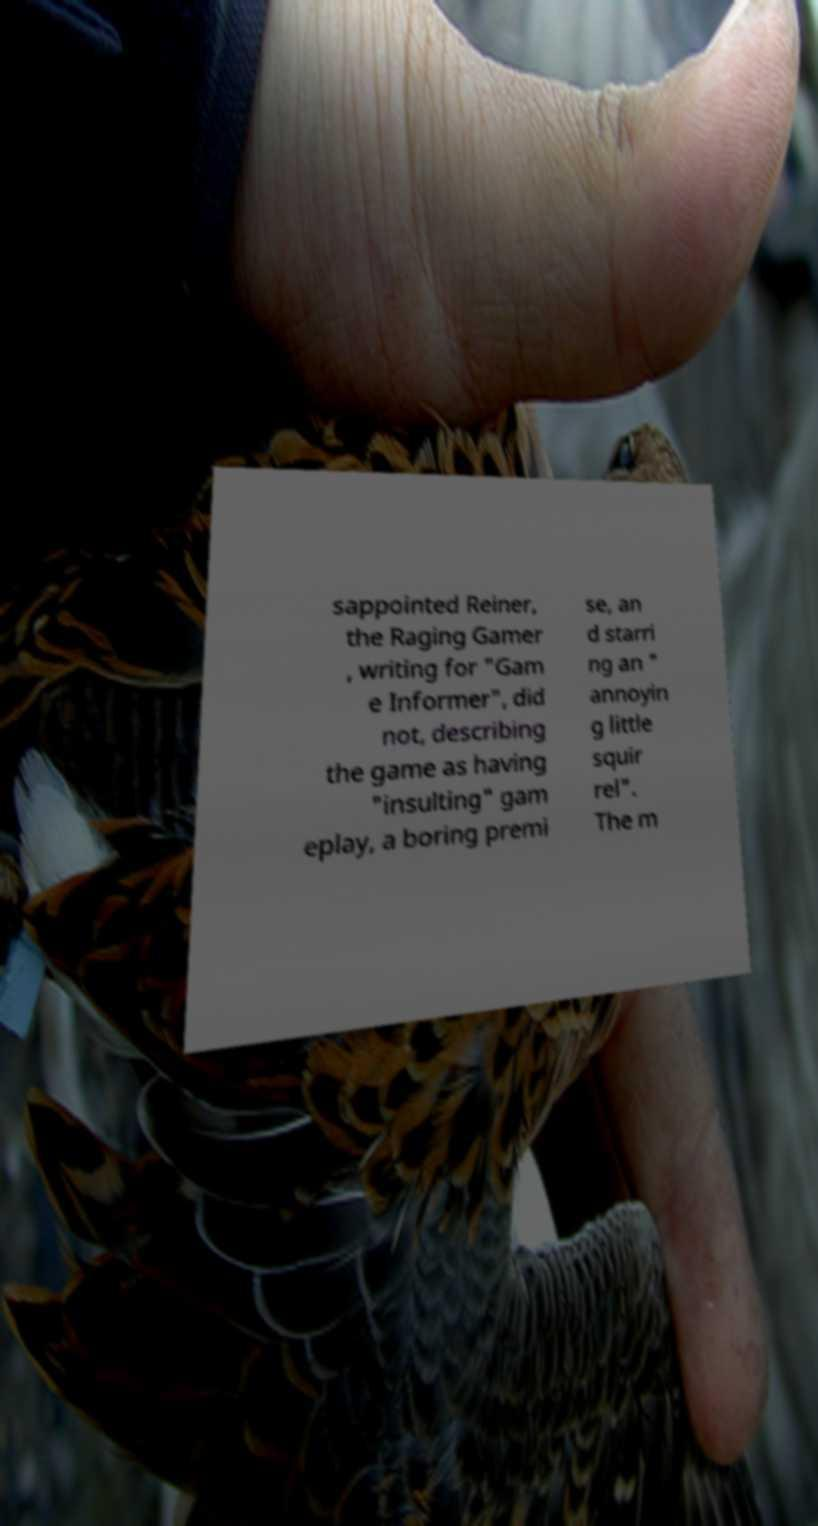Please identify and transcribe the text found in this image. sappointed Reiner, the Raging Gamer , writing for "Gam e Informer", did not, describing the game as having "insulting" gam eplay, a boring premi se, an d starri ng an " annoyin g little squir rel". The m 